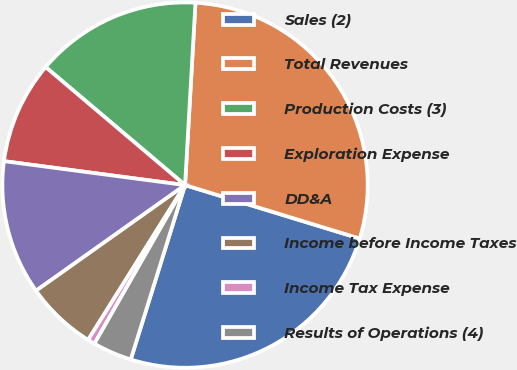Convert chart to OTSL. <chart><loc_0><loc_0><loc_500><loc_500><pie_chart><fcel>Sales (2)<fcel>Total Revenues<fcel>Production Costs (3)<fcel>Exploration Expense<fcel>DD&A<fcel>Income before Income Taxes<fcel>Income Tax Expense<fcel>Results of Operations (4)<nl><fcel>25.08%<fcel>28.82%<fcel>14.73%<fcel>9.09%<fcel>11.91%<fcel>6.28%<fcel>0.64%<fcel>3.46%<nl></chart> 